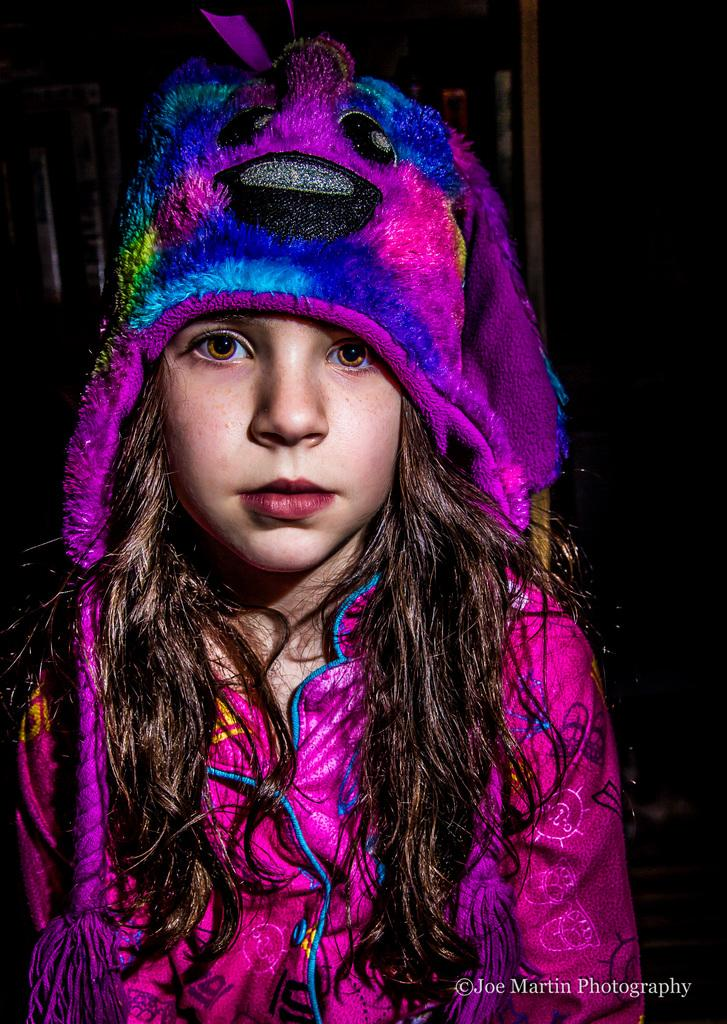Who is the main subject in the image? There is a girl in the center of the image. What is the girl wearing on her head? The girl is wearing a hat. What can be found at the bottom of the image? There is text at the bottom of the image. How would you describe the overall lighting in the image? The background of the image is dark. What type of fear can be seen on the girl's face in the image? There is no indication of fear on the girl's face in the image. What kind of pan is being used by the girl in the image? There is no pan present in the image; the girl is wearing a hat. 